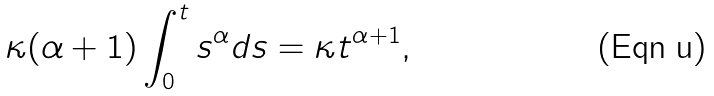Convert formula to latex. <formula><loc_0><loc_0><loc_500><loc_500>\kappa ( \alpha + 1 ) \int _ { 0 } ^ { t } s ^ { \alpha } d s = \kappa t ^ { \alpha + 1 } ,</formula> 